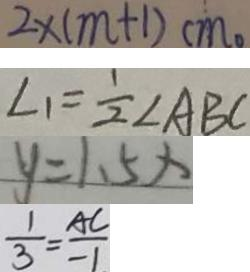Convert formula to latex. <formula><loc_0><loc_0><loc_500><loc_500>2 \times ( m + 1 ) c m 。 
 \angle 1 = \frac { 1 } { 2 } \angle A B C 
 y = 1 . 5 x 
 \frac { 1 } { 3 } = \frac { A C } { - 1 }</formula> 